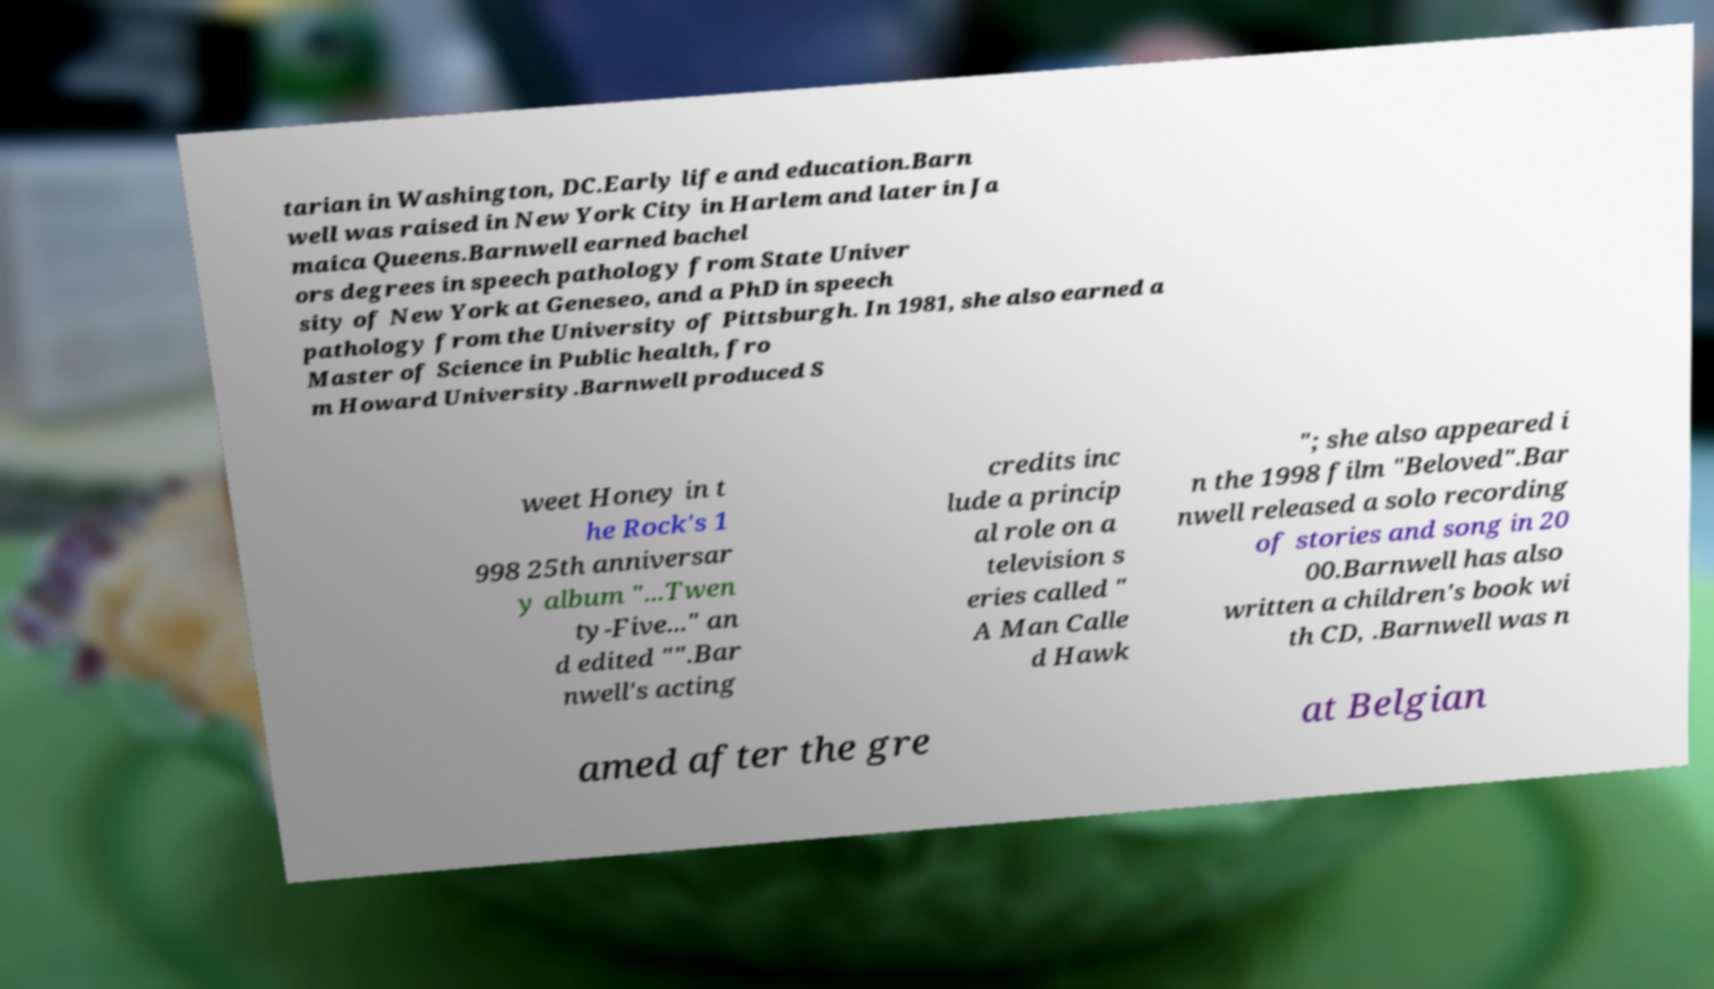Can you read and provide the text displayed in the image?This photo seems to have some interesting text. Can you extract and type it out for me? tarian in Washington, DC.Early life and education.Barn well was raised in New York City in Harlem and later in Ja maica Queens.Barnwell earned bachel ors degrees in speech pathology from State Univer sity of New York at Geneseo, and a PhD in speech pathology from the University of Pittsburgh. In 1981, she also earned a Master of Science in Public health, fro m Howard University.Barnwell produced S weet Honey in t he Rock's 1 998 25th anniversar y album "...Twen ty-Five..." an d edited "".Bar nwell's acting credits inc lude a princip al role on a television s eries called " A Man Calle d Hawk "; she also appeared i n the 1998 film "Beloved".Bar nwell released a solo recording of stories and song in 20 00.Barnwell has also written a children's book wi th CD, .Barnwell was n amed after the gre at Belgian 